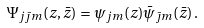Convert formula to latex. <formula><loc_0><loc_0><loc_500><loc_500>\Psi _ { j \bar { \jmath } m } ( z , \bar { z } ) = \psi _ { j m } ( z ) \bar { \psi } _ { \bar { \jmath } m } ( \bar { z } ) \, .</formula> 